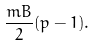<formula> <loc_0><loc_0><loc_500><loc_500>\frac { m B } { 2 } ( p - 1 ) .</formula> 